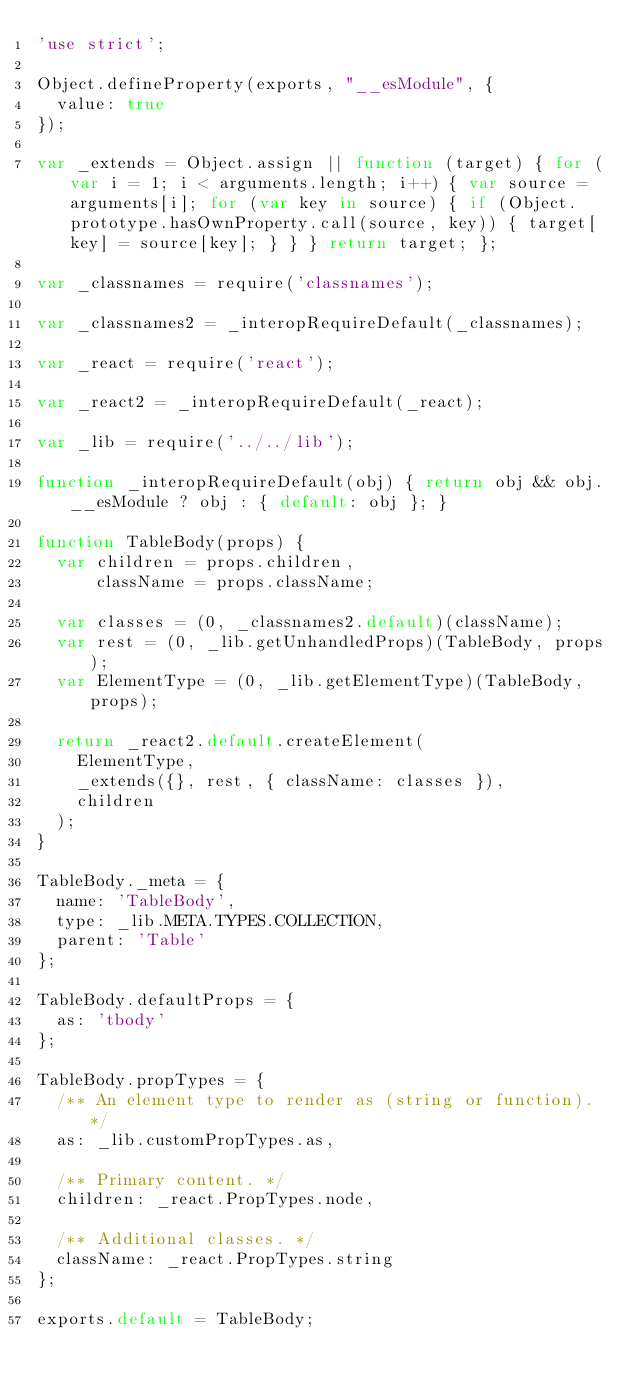Convert code to text. <code><loc_0><loc_0><loc_500><loc_500><_JavaScript_>'use strict';

Object.defineProperty(exports, "__esModule", {
  value: true
});

var _extends = Object.assign || function (target) { for (var i = 1; i < arguments.length; i++) { var source = arguments[i]; for (var key in source) { if (Object.prototype.hasOwnProperty.call(source, key)) { target[key] = source[key]; } } } return target; };

var _classnames = require('classnames');

var _classnames2 = _interopRequireDefault(_classnames);

var _react = require('react');

var _react2 = _interopRequireDefault(_react);

var _lib = require('../../lib');

function _interopRequireDefault(obj) { return obj && obj.__esModule ? obj : { default: obj }; }

function TableBody(props) {
  var children = props.children,
      className = props.className;

  var classes = (0, _classnames2.default)(className);
  var rest = (0, _lib.getUnhandledProps)(TableBody, props);
  var ElementType = (0, _lib.getElementType)(TableBody, props);

  return _react2.default.createElement(
    ElementType,
    _extends({}, rest, { className: classes }),
    children
  );
}

TableBody._meta = {
  name: 'TableBody',
  type: _lib.META.TYPES.COLLECTION,
  parent: 'Table'
};

TableBody.defaultProps = {
  as: 'tbody'
};

TableBody.propTypes = {
  /** An element type to render as (string or function). */
  as: _lib.customPropTypes.as,

  /** Primary content. */
  children: _react.PropTypes.node,

  /** Additional classes. */
  className: _react.PropTypes.string
};

exports.default = TableBody;</code> 